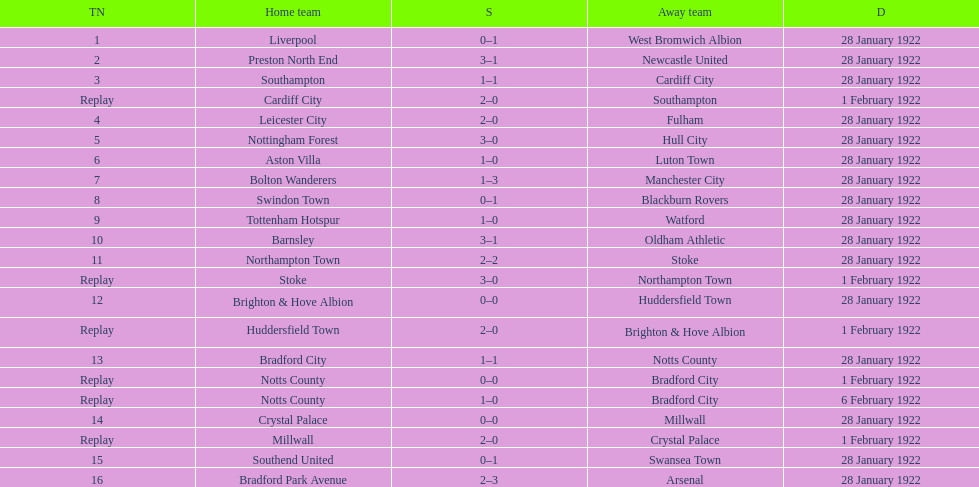How many total points were scored in the second round proper? 45. 